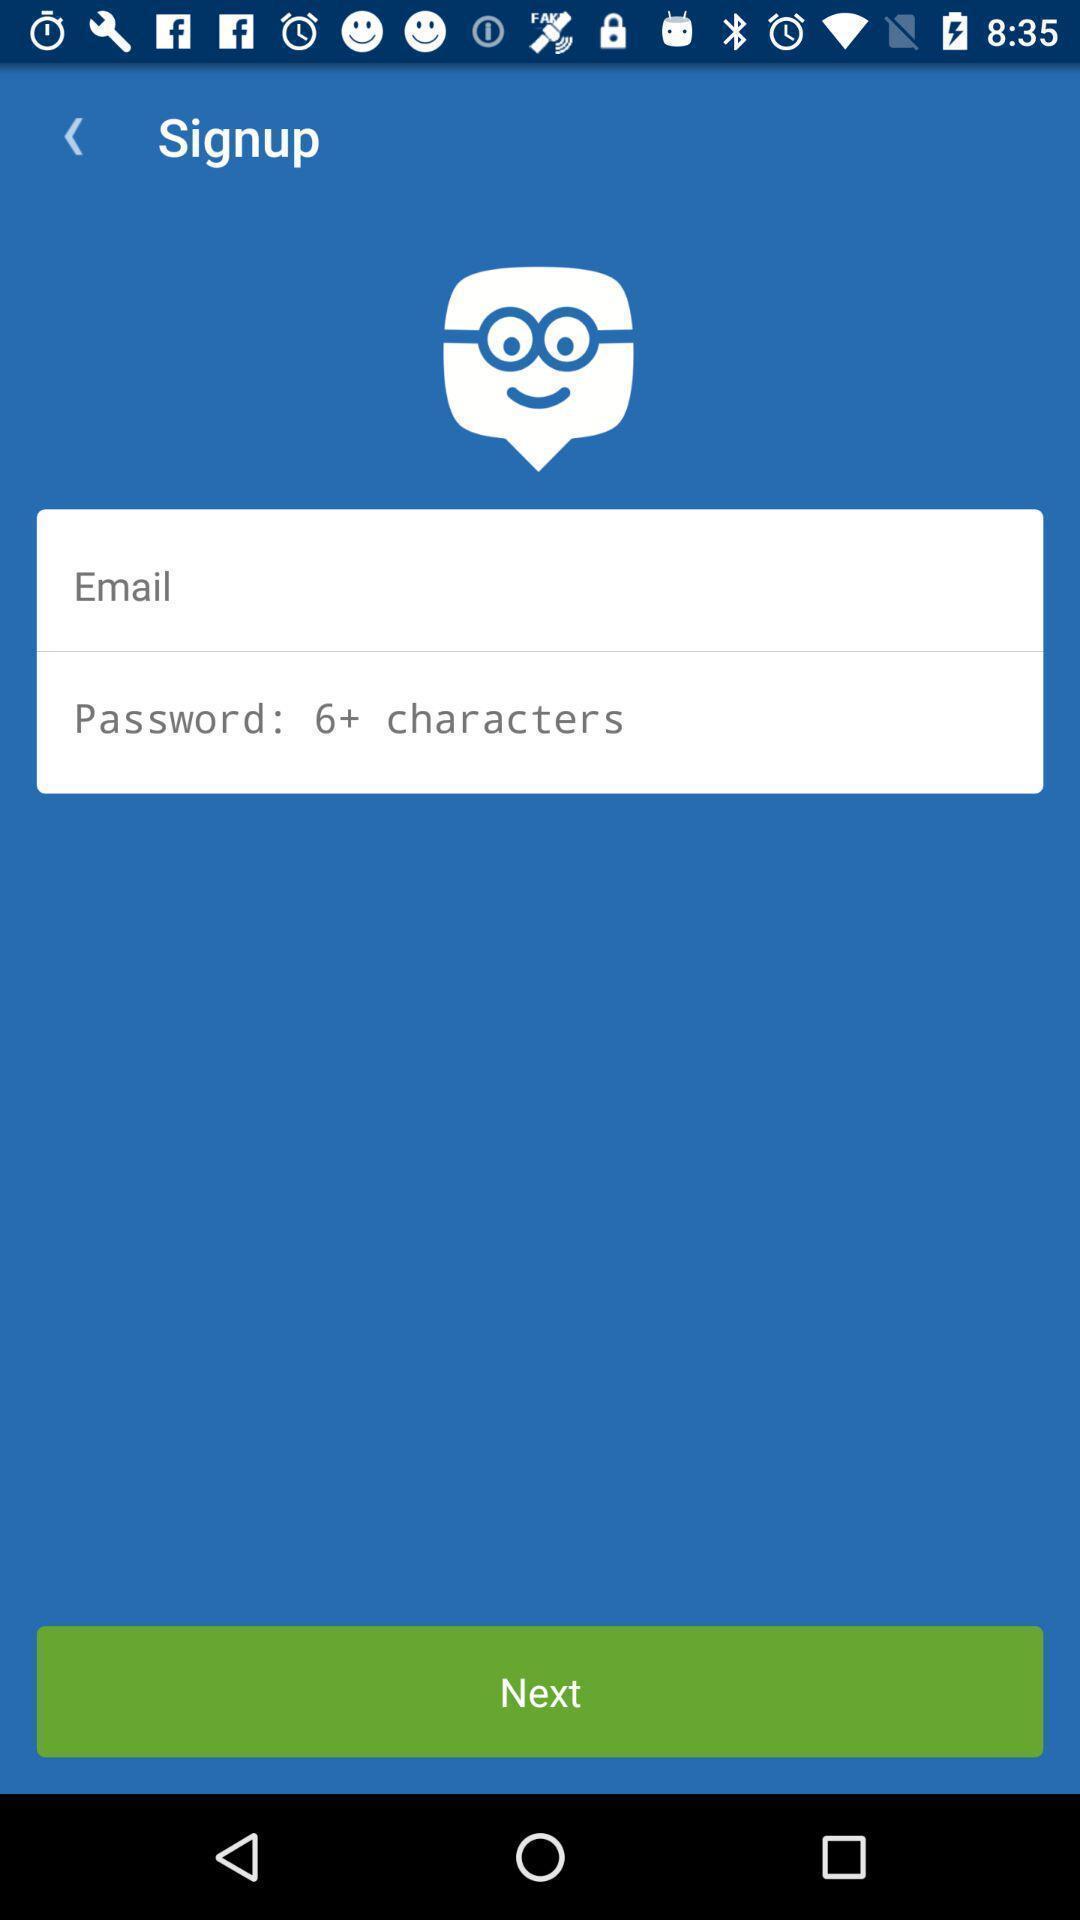Tell me about the visual elements in this screen capture. Sign up page. 